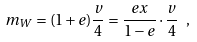Convert formula to latex. <formula><loc_0><loc_0><loc_500><loc_500>m _ { W } = ( 1 + e ) \frac { v } { 4 } = \frac { e x } { 1 - e } \cdot \frac { v } { 4 } \ ,</formula> 